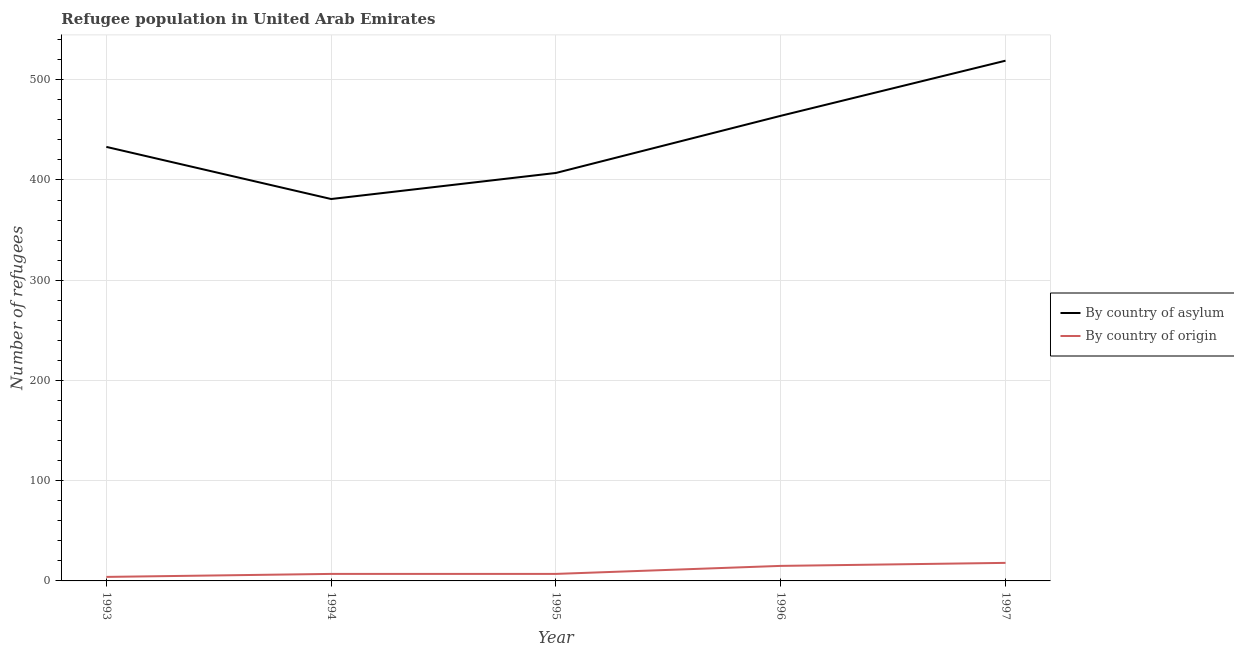Does the line corresponding to number of refugees by country of asylum intersect with the line corresponding to number of refugees by country of origin?
Offer a very short reply. No. Is the number of lines equal to the number of legend labels?
Give a very brief answer. Yes. What is the number of refugees by country of asylum in 1994?
Make the answer very short. 381. Across all years, what is the maximum number of refugees by country of origin?
Make the answer very short. 18. Across all years, what is the minimum number of refugees by country of asylum?
Your response must be concise. 381. What is the total number of refugees by country of origin in the graph?
Keep it short and to the point. 51. What is the difference between the number of refugees by country of asylum in 1993 and that in 1994?
Provide a short and direct response. 52. What is the difference between the number of refugees by country of origin in 1996 and the number of refugees by country of asylum in 1994?
Offer a very short reply. -366. What is the average number of refugees by country of asylum per year?
Give a very brief answer. 440.8. In the year 1996, what is the difference between the number of refugees by country of asylum and number of refugees by country of origin?
Your answer should be compact. 449. In how many years, is the number of refugees by country of asylum greater than 360?
Provide a short and direct response. 5. What is the ratio of the number of refugees by country of asylum in 1993 to that in 1996?
Provide a short and direct response. 0.93. Is the number of refugees by country of origin in 1993 less than that in 1996?
Your answer should be very brief. Yes. What is the difference between the highest and the second highest number of refugees by country of asylum?
Keep it short and to the point. 55. What is the difference between the highest and the lowest number of refugees by country of origin?
Provide a succinct answer. 14. Is the sum of the number of refugees by country of asylum in 1993 and 1996 greater than the maximum number of refugees by country of origin across all years?
Your answer should be very brief. Yes. Does the number of refugees by country of origin monotonically increase over the years?
Provide a succinct answer. No. Is the number of refugees by country of origin strictly greater than the number of refugees by country of asylum over the years?
Your answer should be compact. No. How many years are there in the graph?
Ensure brevity in your answer.  5. Does the graph contain grids?
Keep it short and to the point. Yes. How are the legend labels stacked?
Your answer should be very brief. Vertical. What is the title of the graph?
Offer a terse response. Refugee population in United Arab Emirates. Does "Fixed telephone" appear as one of the legend labels in the graph?
Ensure brevity in your answer.  No. What is the label or title of the Y-axis?
Provide a succinct answer. Number of refugees. What is the Number of refugees in By country of asylum in 1993?
Offer a terse response. 433. What is the Number of refugees of By country of origin in 1993?
Your response must be concise. 4. What is the Number of refugees in By country of asylum in 1994?
Provide a succinct answer. 381. What is the Number of refugees in By country of origin in 1994?
Offer a terse response. 7. What is the Number of refugees in By country of asylum in 1995?
Give a very brief answer. 407. What is the Number of refugees in By country of origin in 1995?
Give a very brief answer. 7. What is the Number of refugees of By country of asylum in 1996?
Keep it short and to the point. 464. What is the Number of refugees in By country of asylum in 1997?
Provide a short and direct response. 519. Across all years, what is the maximum Number of refugees in By country of asylum?
Give a very brief answer. 519. Across all years, what is the maximum Number of refugees in By country of origin?
Your answer should be compact. 18. Across all years, what is the minimum Number of refugees of By country of asylum?
Your answer should be very brief. 381. Across all years, what is the minimum Number of refugees of By country of origin?
Provide a succinct answer. 4. What is the total Number of refugees of By country of asylum in the graph?
Provide a short and direct response. 2204. What is the total Number of refugees in By country of origin in the graph?
Offer a very short reply. 51. What is the difference between the Number of refugees of By country of origin in 1993 and that in 1994?
Give a very brief answer. -3. What is the difference between the Number of refugees in By country of origin in 1993 and that in 1995?
Your answer should be compact. -3. What is the difference between the Number of refugees in By country of asylum in 1993 and that in 1996?
Offer a very short reply. -31. What is the difference between the Number of refugees in By country of asylum in 1993 and that in 1997?
Make the answer very short. -86. What is the difference between the Number of refugees in By country of asylum in 1994 and that in 1995?
Make the answer very short. -26. What is the difference between the Number of refugees in By country of asylum in 1994 and that in 1996?
Ensure brevity in your answer.  -83. What is the difference between the Number of refugees of By country of origin in 1994 and that in 1996?
Your answer should be very brief. -8. What is the difference between the Number of refugees in By country of asylum in 1994 and that in 1997?
Give a very brief answer. -138. What is the difference between the Number of refugees of By country of asylum in 1995 and that in 1996?
Ensure brevity in your answer.  -57. What is the difference between the Number of refugees of By country of asylum in 1995 and that in 1997?
Provide a short and direct response. -112. What is the difference between the Number of refugees in By country of origin in 1995 and that in 1997?
Keep it short and to the point. -11. What is the difference between the Number of refugees in By country of asylum in 1996 and that in 1997?
Keep it short and to the point. -55. What is the difference between the Number of refugees in By country of asylum in 1993 and the Number of refugees in By country of origin in 1994?
Provide a short and direct response. 426. What is the difference between the Number of refugees of By country of asylum in 1993 and the Number of refugees of By country of origin in 1995?
Make the answer very short. 426. What is the difference between the Number of refugees of By country of asylum in 1993 and the Number of refugees of By country of origin in 1996?
Your response must be concise. 418. What is the difference between the Number of refugees of By country of asylum in 1993 and the Number of refugees of By country of origin in 1997?
Provide a short and direct response. 415. What is the difference between the Number of refugees of By country of asylum in 1994 and the Number of refugees of By country of origin in 1995?
Offer a very short reply. 374. What is the difference between the Number of refugees in By country of asylum in 1994 and the Number of refugees in By country of origin in 1996?
Provide a short and direct response. 366. What is the difference between the Number of refugees of By country of asylum in 1994 and the Number of refugees of By country of origin in 1997?
Ensure brevity in your answer.  363. What is the difference between the Number of refugees in By country of asylum in 1995 and the Number of refugees in By country of origin in 1996?
Provide a short and direct response. 392. What is the difference between the Number of refugees of By country of asylum in 1995 and the Number of refugees of By country of origin in 1997?
Your response must be concise. 389. What is the difference between the Number of refugees in By country of asylum in 1996 and the Number of refugees in By country of origin in 1997?
Your answer should be compact. 446. What is the average Number of refugees in By country of asylum per year?
Your answer should be very brief. 440.8. What is the average Number of refugees in By country of origin per year?
Offer a terse response. 10.2. In the year 1993, what is the difference between the Number of refugees in By country of asylum and Number of refugees in By country of origin?
Your response must be concise. 429. In the year 1994, what is the difference between the Number of refugees in By country of asylum and Number of refugees in By country of origin?
Keep it short and to the point. 374. In the year 1995, what is the difference between the Number of refugees of By country of asylum and Number of refugees of By country of origin?
Provide a short and direct response. 400. In the year 1996, what is the difference between the Number of refugees of By country of asylum and Number of refugees of By country of origin?
Your answer should be very brief. 449. In the year 1997, what is the difference between the Number of refugees in By country of asylum and Number of refugees in By country of origin?
Your response must be concise. 501. What is the ratio of the Number of refugees in By country of asylum in 1993 to that in 1994?
Give a very brief answer. 1.14. What is the ratio of the Number of refugees of By country of asylum in 1993 to that in 1995?
Provide a short and direct response. 1.06. What is the ratio of the Number of refugees in By country of asylum in 1993 to that in 1996?
Your answer should be very brief. 0.93. What is the ratio of the Number of refugees of By country of origin in 1993 to that in 1996?
Keep it short and to the point. 0.27. What is the ratio of the Number of refugees of By country of asylum in 1993 to that in 1997?
Keep it short and to the point. 0.83. What is the ratio of the Number of refugees in By country of origin in 1993 to that in 1997?
Your answer should be compact. 0.22. What is the ratio of the Number of refugees in By country of asylum in 1994 to that in 1995?
Give a very brief answer. 0.94. What is the ratio of the Number of refugees in By country of origin in 1994 to that in 1995?
Your answer should be very brief. 1. What is the ratio of the Number of refugees of By country of asylum in 1994 to that in 1996?
Give a very brief answer. 0.82. What is the ratio of the Number of refugees in By country of origin in 1994 to that in 1996?
Your answer should be very brief. 0.47. What is the ratio of the Number of refugees of By country of asylum in 1994 to that in 1997?
Your answer should be compact. 0.73. What is the ratio of the Number of refugees in By country of origin in 1994 to that in 1997?
Make the answer very short. 0.39. What is the ratio of the Number of refugees of By country of asylum in 1995 to that in 1996?
Your response must be concise. 0.88. What is the ratio of the Number of refugees of By country of origin in 1995 to that in 1996?
Keep it short and to the point. 0.47. What is the ratio of the Number of refugees in By country of asylum in 1995 to that in 1997?
Provide a short and direct response. 0.78. What is the ratio of the Number of refugees in By country of origin in 1995 to that in 1997?
Provide a short and direct response. 0.39. What is the ratio of the Number of refugees in By country of asylum in 1996 to that in 1997?
Your answer should be very brief. 0.89. What is the difference between the highest and the second highest Number of refugees in By country of asylum?
Keep it short and to the point. 55. What is the difference between the highest and the lowest Number of refugees of By country of asylum?
Provide a succinct answer. 138. What is the difference between the highest and the lowest Number of refugees of By country of origin?
Ensure brevity in your answer.  14. 